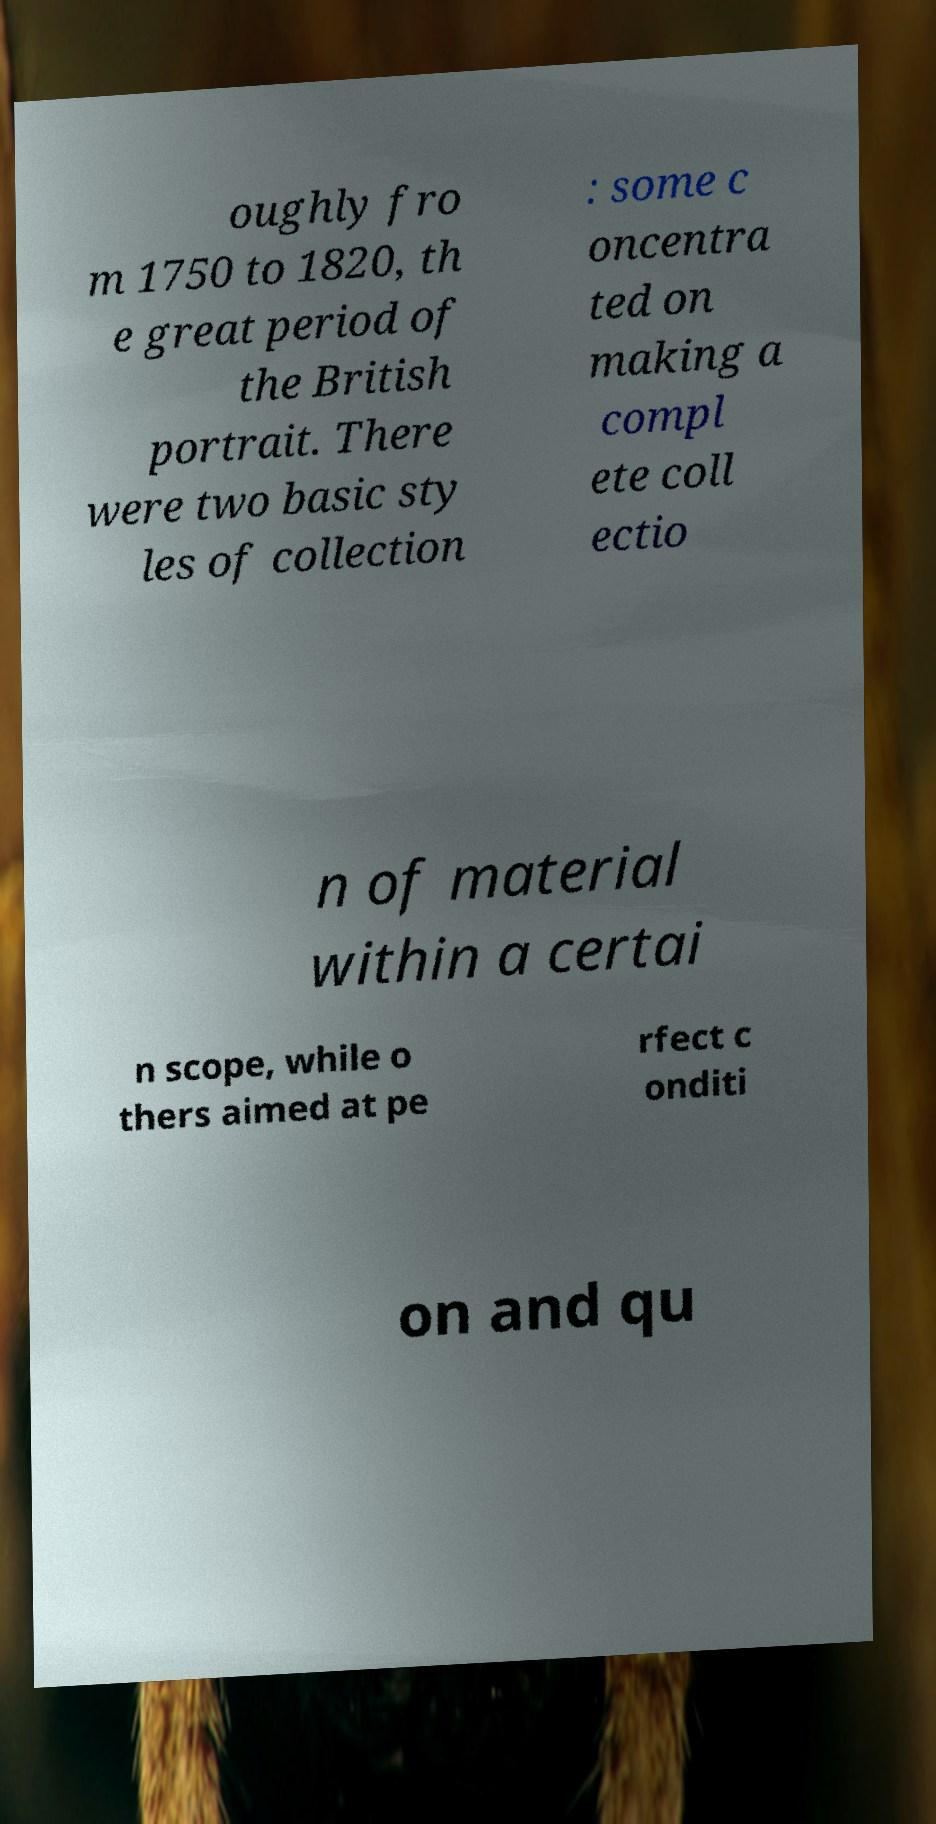Can you read and provide the text displayed in the image?This photo seems to have some interesting text. Can you extract and type it out for me? oughly fro m 1750 to 1820, th e great period of the British portrait. There were two basic sty les of collection : some c oncentra ted on making a compl ete coll ectio n of material within a certai n scope, while o thers aimed at pe rfect c onditi on and qu 